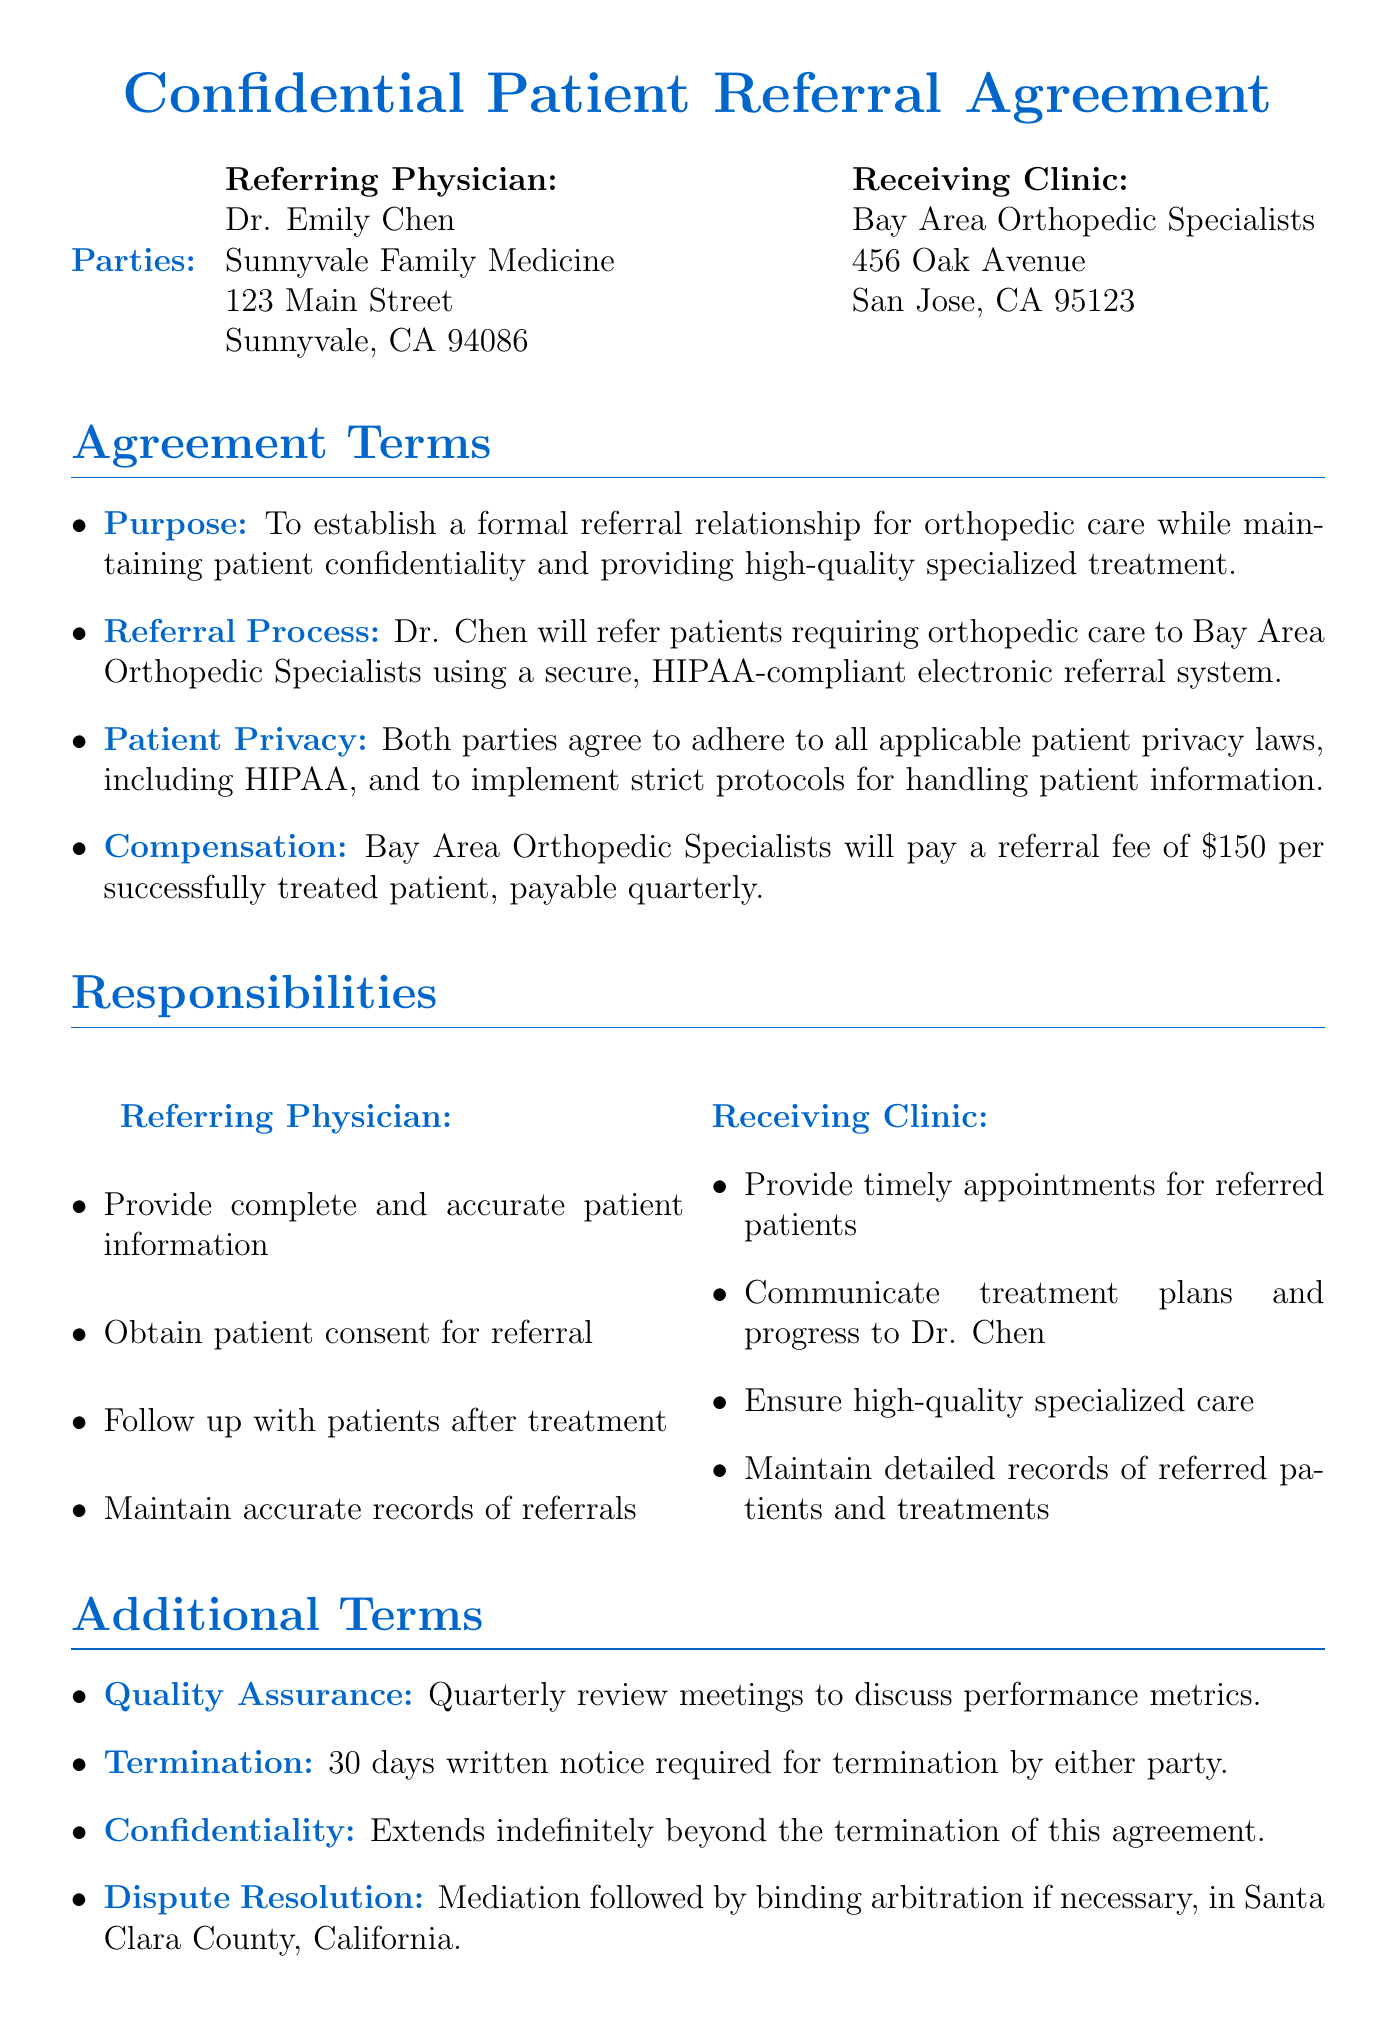What is the name of the referring physician? The referring physician's name is explicitly mentioned in the document as Dr. Emily Chen.
Answer: Dr. Emily Chen What is the address of Bay Area Orthopedic Specialists? The address of the receiving clinic is provided in the document as 456 Oak Avenue, San Jose, CA 95123.
Answer: 456 Oak Avenue, San Jose, CA 95123 How much is the referral fee per patient? The referral fee is specified in the compensation section of the document as $150 for each successfully treated patient.
Answer: $150 What is the notice period required for termination? The termination clause states that a 30 days written notice is required for termination by either party.
Answer: 30 days What are the performance metrics for quality assurance? The document lists several performance metrics, including patient satisfaction scores, treatment success rates, timeliness of appointments, and communication effectiveness.
Answer: Patient satisfaction scores, treatment success rates, timeliness of appointments, communication effectiveness Who has to maintain professional liability insurance? Both parties, referring physician and receiving clinic, are required to maintain professional liability insurance as per the insurance requirements section of the document.
Answer: Both parties What is the initial term of the agreement? The agreement duration specifies that the initial term is set for one year from the effective date.
Answer: One year How will disputes be resolved? According to the document, disputes are to be resolved through mediation followed by binding arbitration if necessary, in Santa Clara County, California.
Answer: Mediation followed by binding arbitration What is the duration of the confidentiality clause? The confidentiality clause indicates that its duration extends indefinitely beyond the termination of this agreement.
Answer: Indefinitely 